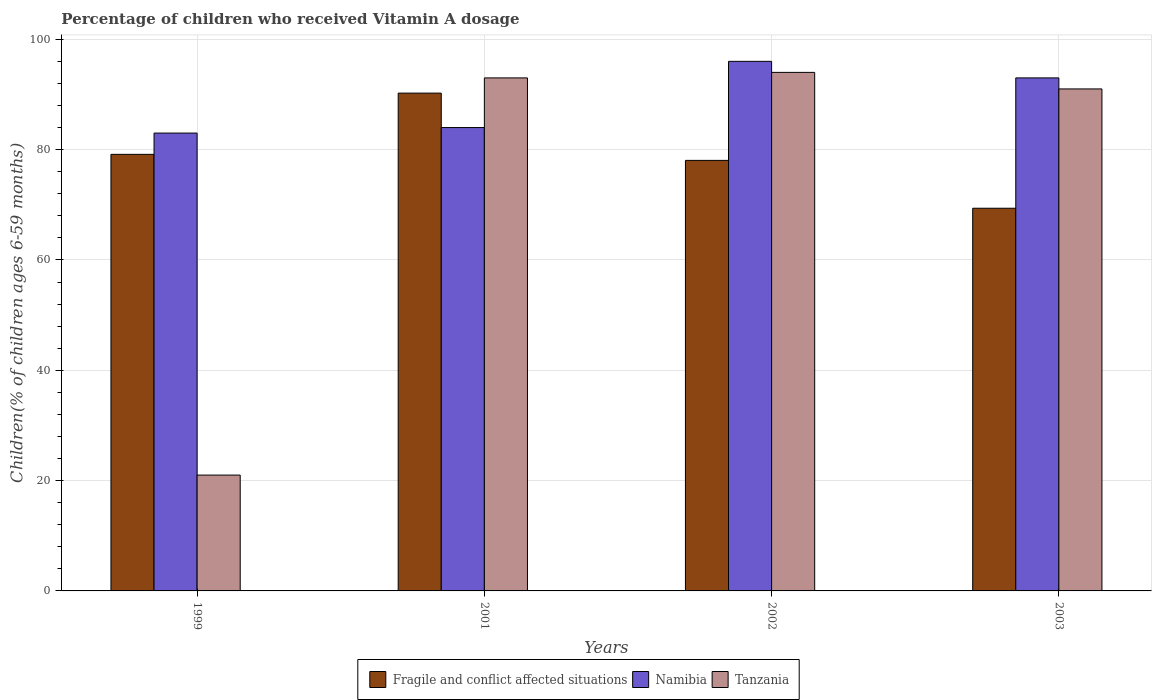How many different coloured bars are there?
Offer a terse response. 3. How many groups of bars are there?
Offer a terse response. 4. Are the number of bars on each tick of the X-axis equal?
Offer a very short reply. Yes. How many bars are there on the 3rd tick from the left?
Ensure brevity in your answer.  3. What is the percentage of children who received Vitamin A dosage in Fragile and conflict affected situations in 2001?
Provide a succinct answer. 90.24. Across all years, what is the maximum percentage of children who received Vitamin A dosage in Tanzania?
Your response must be concise. 94. In which year was the percentage of children who received Vitamin A dosage in Namibia minimum?
Keep it short and to the point. 1999. What is the total percentage of children who received Vitamin A dosage in Namibia in the graph?
Make the answer very short. 356. What is the difference between the percentage of children who received Vitamin A dosage in Namibia in 2001 and that in 2002?
Make the answer very short. -12. What is the difference between the percentage of children who received Vitamin A dosage in Tanzania in 2003 and the percentage of children who received Vitamin A dosage in Fragile and conflict affected situations in 2002?
Your response must be concise. 12.95. What is the average percentage of children who received Vitamin A dosage in Tanzania per year?
Offer a terse response. 74.75. In the year 2003, what is the difference between the percentage of children who received Vitamin A dosage in Tanzania and percentage of children who received Vitamin A dosage in Fragile and conflict affected situations?
Make the answer very short. 21.63. In how many years, is the percentage of children who received Vitamin A dosage in Fragile and conflict affected situations greater than 68 %?
Provide a succinct answer. 4. What is the ratio of the percentage of children who received Vitamin A dosage in Tanzania in 2002 to that in 2003?
Keep it short and to the point. 1.03. Is the difference between the percentage of children who received Vitamin A dosage in Tanzania in 2001 and 2003 greater than the difference between the percentage of children who received Vitamin A dosage in Fragile and conflict affected situations in 2001 and 2003?
Keep it short and to the point. No. What is the difference between the highest and the lowest percentage of children who received Vitamin A dosage in Fragile and conflict affected situations?
Your response must be concise. 20.87. In how many years, is the percentage of children who received Vitamin A dosage in Namibia greater than the average percentage of children who received Vitamin A dosage in Namibia taken over all years?
Provide a short and direct response. 2. Is the sum of the percentage of children who received Vitamin A dosage in Tanzania in 2001 and 2003 greater than the maximum percentage of children who received Vitamin A dosage in Fragile and conflict affected situations across all years?
Ensure brevity in your answer.  Yes. What does the 3rd bar from the left in 2003 represents?
Your response must be concise. Tanzania. What does the 2nd bar from the right in 2001 represents?
Make the answer very short. Namibia. Is it the case that in every year, the sum of the percentage of children who received Vitamin A dosage in Fragile and conflict affected situations and percentage of children who received Vitamin A dosage in Namibia is greater than the percentage of children who received Vitamin A dosage in Tanzania?
Ensure brevity in your answer.  Yes. How many bars are there?
Your response must be concise. 12. What is the difference between two consecutive major ticks on the Y-axis?
Keep it short and to the point. 20. Does the graph contain any zero values?
Your answer should be very brief. No. Where does the legend appear in the graph?
Provide a short and direct response. Bottom center. How many legend labels are there?
Provide a succinct answer. 3. How are the legend labels stacked?
Your answer should be compact. Horizontal. What is the title of the graph?
Keep it short and to the point. Percentage of children who received Vitamin A dosage. Does "Sao Tome and Principe" appear as one of the legend labels in the graph?
Make the answer very short. No. What is the label or title of the X-axis?
Your answer should be very brief. Years. What is the label or title of the Y-axis?
Provide a short and direct response. Children(% of children ages 6-59 months). What is the Children(% of children ages 6-59 months) in Fragile and conflict affected situations in 1999?
Offer a very short reply. 79.14. What is the Children(% of children ages 6-59 months) of Fragile and conflict affected situations in 2001?
Offer a terse response. 90.24. What is the Children(% of children ages 6-59 months) of Tanzania in 2001?
Provide a short and direct response. 93. What is the Children(% of children ages 6-59 months) of Fragile and conflict affected situations in 2002?
Make the answer very short. 78.05. What is the Children(% of children ages 6-59 months) in Namibia in 2002?
Your answer should be compact. 96. What is the Children(% of children ages 6-59 months) in Tanzania in 2002?
Provide a succinct answer. 94. What is the Children(% of children ages 6-59 months) of Fragile and conflict affected situations in 2003?
Make the answer very short. 69.37. What is the Children(% of children ages 6-59 months) of Namibia in 2003?
Provide a short and direct response. 93. What is the Children(% of children ages 6-59 months) in Tanzania in 2003?
Give a very brief answer. 91. Across all years, what is the maximum Children(% of children ages 6-59 months) of Fragile and conflict affected situations?
Give a very brief answer. 90.24. Across all years, what is the maximum Children(% of children ages 6-59 months) of Namibia?
Offer a terse response. 96. Across all years, what is the maximum Children(% of children ages 6-59 months) of Tanzania?
Ensure brevity in your answer.  94. Across all years, what is the minimum Children(% of children ages 6-59 months) of Fragile and conflict affected situations?
Provide a succinct answer. 69.37. Across all years, what is the minimum Children(% of children ages 6-59 months) of Namibia?
Provide a succinct answer. 83. What is the total Children(% of children ages 6-59 months) of Fragile and conflict affected situations in the graph?
Make the answer very short. 316.81. What is the total Children(% of children ages 6-59 months) in Namibia in the graph?
Provide a short and direct response. 356. What is the total Children(% of children ages 6-59 months) in Tanzania in the graph?
Make the answer very short. 299. What is the difference between the Children(% of children ages 6-59 months) in Fragile and conflict affected situations in 1999 and that in 2001?
Keep it short and to the point. -11.1. What is the difference between the Children(% of children ages 6-59 months) of Tanzania in 1999 and that in 2001?
Keep it short and to the point. -72. What is the difference between the Children(% of children ages 6-59 months) of Fragile and conflict affected situations in 1999 and that in 2002?
Keep it short and to the point. 1.09. What is the difference between the Children(% of children ages 6-59 months) in Tanzania in 1999 and that in 2002?
Your answer should be compact. -73. What is the difference between the Children(% of children ages 6-59 months) in Fragile and conflict affected situations in 1999 and that in 2003?
Keep it short and to the point. 9.77. What is the difference between the Children(% of children ages 6-59 months) in Namibia in 1999 and that in 2003?
Your answer should be compact. -10. What is the difference between the Children(% of children ages 6-59 months) in Tanzania in 1999 and that in 2003?
Ensure brevity in your answer.  -70. What is the difference between the Children(% of children ages 6-59 months) of Fragile and conflict affected situations in 2001 and that in 2002?
Provide a succinct answer. 12.19. What is the difference between the Children(% of children ages 6-59 months) in Namibia in 2001 and that in 2002?
Offer a terse response. -12. What is the difference between the Children(% of children ages 6-59 months) in Tanzania in 2001 and that in 2002?
Provide a succinct answer. -1. What is the difference between the Children(% of children ages 6-59 months) of Fragile and conflict affected situations in 2001 and that in 2003?
Provide a succinct answer. 20.87. What is the difference between the Children(% of children ages 6-59 months) of Tanzania in 2001 and that in 2003?
Your answer should be very brief. 2. What is the difference between the Children(% of children ages 6-59 months) in Fragile and conflict affected situations in 2002 and that in 2003?
Offer a terse response. 8.68. What is the difference between the Children(% of children ages 6-59 months) of Namibia in 2002 and that in 2003?
Offer a terse response. 3. What is the difference between the Children(% of children ages 6-59 months) of Fragile and conflict affected situations in 1999 and the Children(% of children ages 6-59 months) of Namibia in 2001?
Your answer should be compact. -4.86. What is the difference between the Children(% of children ages 6-59 months) in Fragile and conflict affected situations in 1999 and the Children(% of children ages 6-59 months) in Tanzania in 2001?
Give a very brief answer. -13.86. What is the difference between the Children(% of children ages 6-59 months) of Namibia in 1999 and the Children(% of children ages 6-59 months) of Tanzania in 2001?
Your answer should be very brief. -10. What is the difference between the Children(% of children ages 6-59 months) in Fragile and conflict affected situations in 1999 and the Children(% of children ages 6-59 months) in Namibia in 2002?
Keep it short and to the point. -16.86. What is the difference between the Children(% of children ages 6-59 months) in Fragile and conflict affected situations in 1999 and the Children(% of children ages 6-59 months) in Tanzania in 2002?
Provide a short and direct response. -14.86. What is the difference between the Children(% of children ages 6-59 months) of Namibia in 1999 and the Children(% of children ages 6-59 months) of Tanzania in 2002?
Make the answer very short. -11. What is the difference between the Children(% of children ages 6-59 months) in Fragile and conflict affected situations in 1999 and the Children(% of children ages 6-59 months) in Namibia in 2003?
Keep it short and to the point. -13.86. What is the difference between the Children(% of children ages 6-59 months) in Fragile and conflict affected situations in 1999 and the Children(% of children ages 6-59 months) in Tanzania in 2003?
Offer a very short reply. -11.86. What is the difference between the Children(% of children ages 6-59 months) in Fragile and conflict affected situations in 2001 and the Children(% of children ages 6-59 months) in Namibia in 2002?
Your response must be concise. -5.76. What is the difference between the Children(% of children ages 6-59 months) in Fragile and conflict affected situations in 2001 and the Children(% of children ages 6-59 months) in Tanzania in 2002?
Keep it short and to the point. -3.76. What is the difference between the Children(% of children ages 6-59 months) in Namibia in 2001 and the Children(% of children ages 6-59 months) in Tanzania in 2002?
Offer a very short reply. -10. What is the difference between the Children(% of children ages 6-59 months) in Fragile and conflict affected situations in 2001 and the Children(% of children ages 6-59 months) in Namibia in 2003?
Make the answer very short. -2.76. What is the difference between the Children(% of children ages 6-59 months) of Fragile and conflict affected situations in 2001 and the Children(% of children ages 6-59 months) of Tanzania in 2003?
Keep it short and to the point. -0.76. What is the difference between the Children(% of children ages 6-59 months) in Namibia in 2001 and the Children(% of children ages 6-59 months) in Tanzania in 2003?
Offer a very short reply. -7. What is the difference between the Children(% of children ages 6-59 months) of Fragile and conflict affected situations in 2002 and the Children(% of children ages 6-59 months) of Namibia in 2003?
Offer a very short reply. -14.95. What is the difference between the Children(% of children ages 6-59 months) in Fragile and conflict affected situations in 2002 and the Children(% of children ages 6-59 months) in Tanzania in 2003?
Give a very brief answer. -12.95. What is the average Children(% of children ages 6-59 months) in Fragile and conflict affected situations per year?
Your answer should be compact. 79.2. What is the average Children(% of children ages 6-59 months) in Namibia per year?
Give a very brief answer. 89. What is the average Children(% of children ages 6-59 months) in Tanzania per year?
Offer a terse response. 74.75. In the year 1999, what is the difference between the Children(% of children ages 6-59 months) in Fragile and conflict affected situations and Children(% of children ages 6-59 months) in Namibia?
Keep it short and to the point. -3.86. In the year 1999, what is the difference between the Children(% of children ages 6-59 months) in Fragile and conflict affected situations and Children(% of children ages 6-59 months) in Tanzania?
Provide a short and direct response. 58.14. In the year 1999, what is the difference between the Children(% of children ages 6-59 months) in Namibia and Children(% of children ages 6-59 months) in Tanzania?
Provide a short and direct response. 62. In the year 2001, what is the difference between the Children(% of children ages 6-59 months) in Fragile and conflict affected situations and Children(% of children ages 6-59 months) in Namibia?
Provide a succinct answer. 6.24. In the year 2001, what is the difference between the Children(% of children ages 6-59 months) of Fragile and conflict affected situations and Children(% of children ages 6-59 months) of Tanzania?
Your response must be concise. -2.76. In the year 2002, what is the difference between the Children(% of children ages 6-59 months) of Fragile and conflict affected situations and Children(% of children ages 6-59 months) of Namibia?
Your answer should be compact. -17.95. In the year 2002, what is the difference between the Children(% of children ages 6-59 months) in Fragile and conflict affected situations and Children(% of children ages 6-59 months) in Tanzania?
Provide a succinct answer. -15.95. In the year 2003, what is the difference between the Children(% of children ages 6-59 months) of Fragile and conflict affected situations and Children(% of children ages 6-59 months) of Namibia?
Provide a short and direct response. -23.63. In the year 2003, what is the difference between the Children(% of children ages 6-59 months) of Fragile and conflict affected situations and Children(% of children ages 6-59 months) of Tanzania?
Provide a short and direct response. -21.63. What is the ratio of the Children(% of children ages 6-59 months) of Fragile and conflict affected situations in 1999 to that in 2001?
Make the answer very short. 0.88. What is the ratio of the Children(% of children ages 6-59 months) of Namibia in 1999 to that in 2001?
Offer a very short reply. 0.99. What is the ratio of the Children(% of children ages 6-59 months) of Tanzania in 1999 to that in 2001?
Offer a very short reply. 0.23. What is the ratio of the Children(% of children ages 6-59 months) of Fragile and conflict affected situations in 1999 to that in 2002?
Ensure brevity in your answer.  1.01. What is the ratio of the Children(% of children ages 6-59 months) of Namibia in 1999 to that in 2002?
Offer a very short reply. 0.86. What is the ratio of the Children(% of children ages 6-59 months) in Tanzania in 1999 to that in 2002?
Make the answer very short. 0.22. What is the ratio of the Children(% of children ages 6-59 months) of Fragile and conflict affected situations in 1999 to that in 2003?
Offer a terse response. 1.14. What is the ratio of the Children(% of children ages 6-59 months) of Namibia in 1999 to that in 2003?
Keep it short and to the point. 0.89. What is the ratio of the Children(% of children ages 6-59 months) of Tanzania in 1999 to that in 2003?
Offer a very short reply. 0.23. What is the ratio of the Children(% of children ages 6-59 months) of Fragile and conflict affected situations in 2001 to that in 2002?
Your answer should be compact. 1.16. What is the ratio of the Children(% of children ages 6-59 months) of Namibia in 2001 to that in 2002?
Your response must be concise. 0.88. What is the ratio of the Children(% of children ages 6-59 months) in Fragile and conflict affected situations in 2001 to that in 2003?
Your answer should be compact. 1.3. What is the ratio of the Children(% of children ages 6-59 months) of Namibia in 2001 to that in 2003?
Keep it short and to the point. 0.9. What is the ratio of the Children(% of children ages 6-59 months) of Tanzania in 2001 to that in 2003?
Give a very brief answer. 1.02. What is the ratio of the Children(% of children ages 6-59 months) of Fragile and conflict affected situations in 2002 to that in 2003?
Provide a succinct answer. 1.13. What is the ratio of the Children(% of children ages 6-59 months) of Namibia in 2002 to that in 2003?
Offer a very short reply. 1.03. What is the ratio of the Children(% of children ages 6-59 months) of Tanzania in 2002 to that in 2003?
Keep it short and to the point. 1.03. What is the difference between the highest and the second highest Children(% of children ages 6-59 months) in Fragile and conflict affected situations?
Provide a short and direct response. 11.1. What is the difference between the highest and the second highest Children(% of children ages 6-59 months) in Tanzania?
Your answer should be compact. 1. What is the difference between the highest and the lowest Children(% of children ages 6-59 months) of Fragile and conflict affected situations?
Your answer should be very brief. 20.87. 